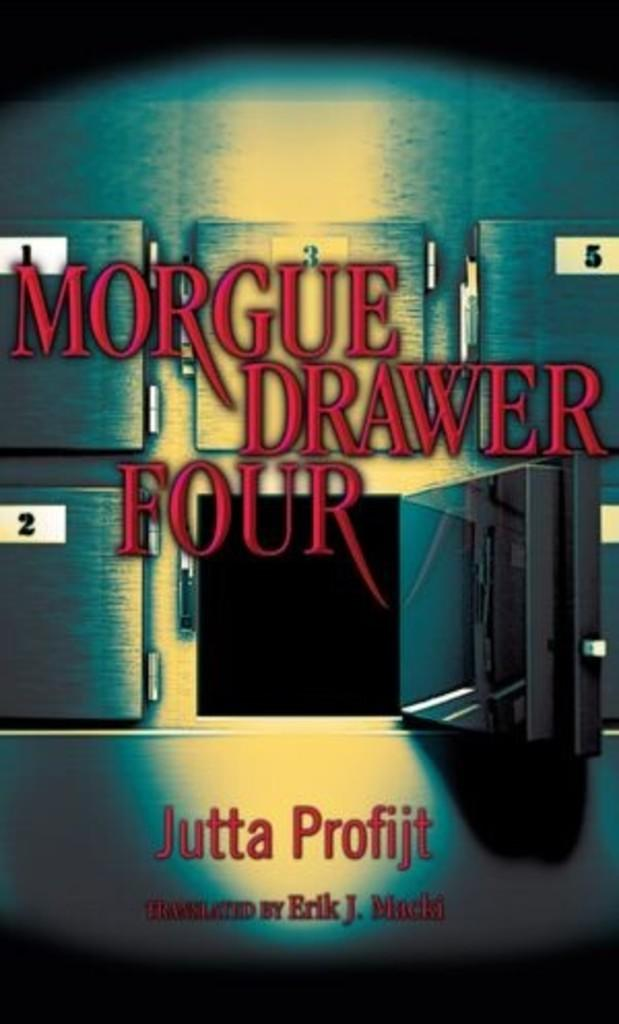<image>
Create a compact narrative representing the image presented. A book by Jutta Profijt show drawers in a morgue. 